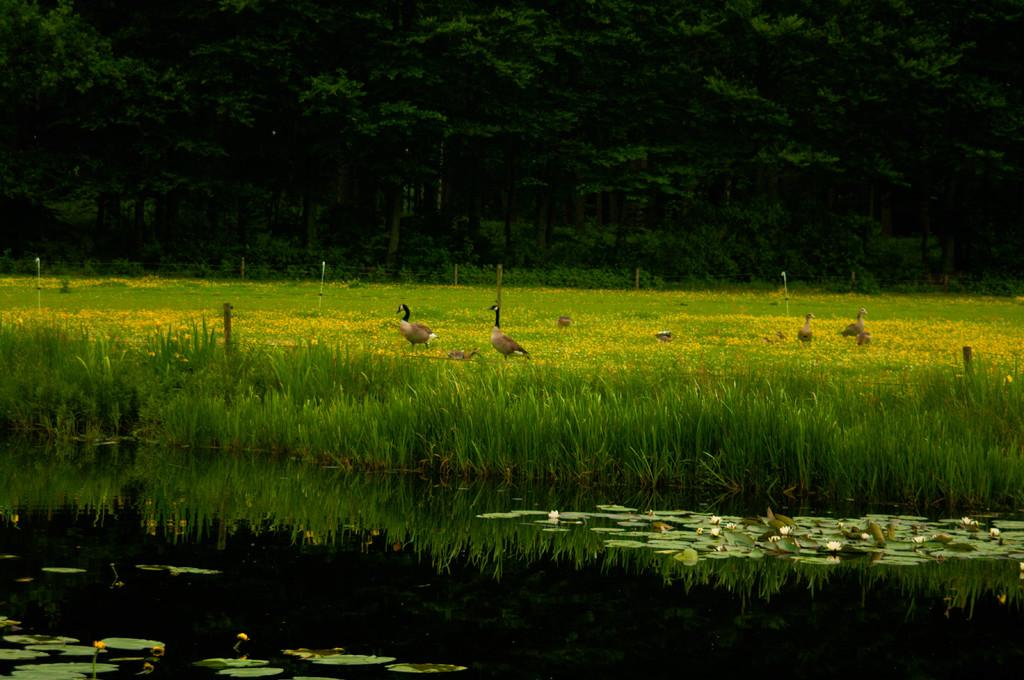What is in the foreground of the image? There is water in the foreground of the image. What is floating on the water? Green leaves are floating on the water. What type of vegetation is visible in the image? There is green grass visible in the image. What type of animals are present in the image? Birds are present in the image. What can be seen in the background of the image? Trees are visible in the background of the image. What type of cap is the quartz wearing in the image? There is no quartz or cap present in the image. 